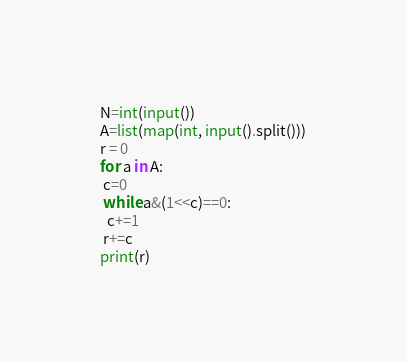Convert code to text. <code><loc_0><loc_0><loc_500><loc_500><_Python_>N=int(input())
A=list(map(int, input().split()))
r = 0
for a in A:
 c=0
 while a&(1<<c)==0:
  c+=1
 r+=c
print(r)
</code> 